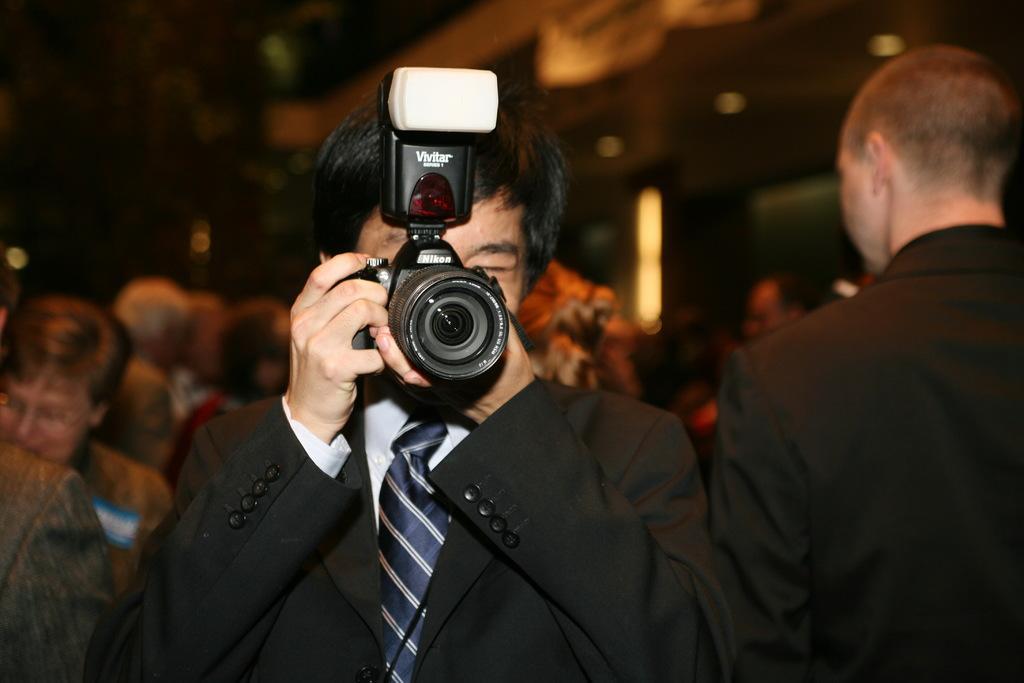In one or two sentences, can you explain what this image depicts? There is a group of a people. In the center we have a person. He is holding a camera and his wearing a colorful black shirt ,tie. 